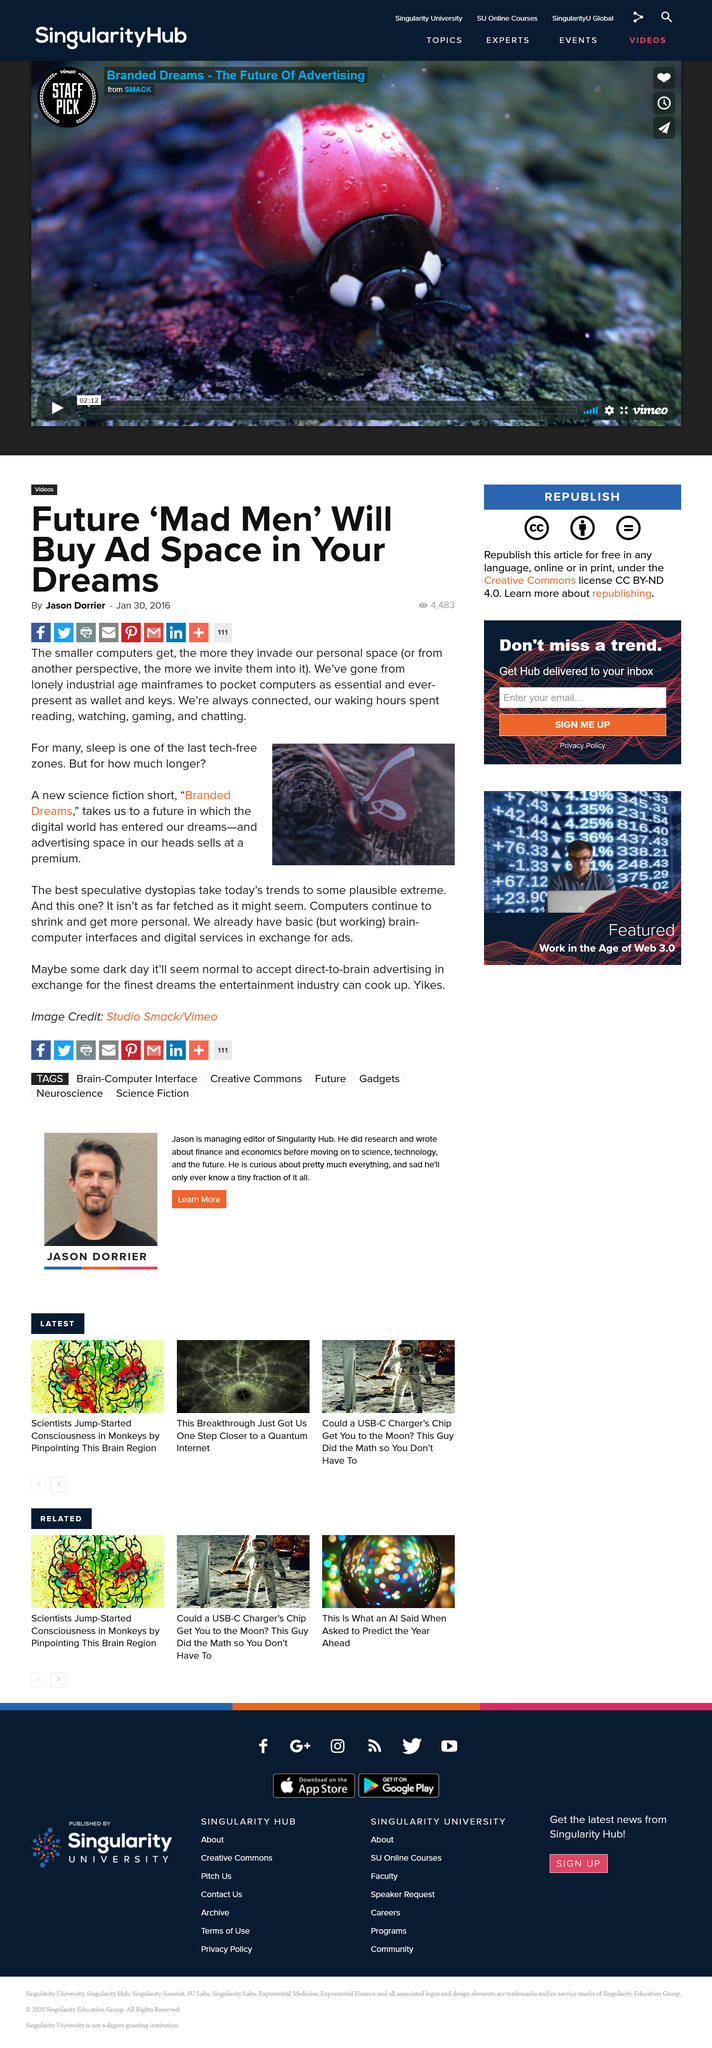Draw attention to some important aspects in this diagram. Yes, computers are continuing to shrink. Yes, computers are continuing to become more personal. The science fiction short referenced is "Branded Dreams". 